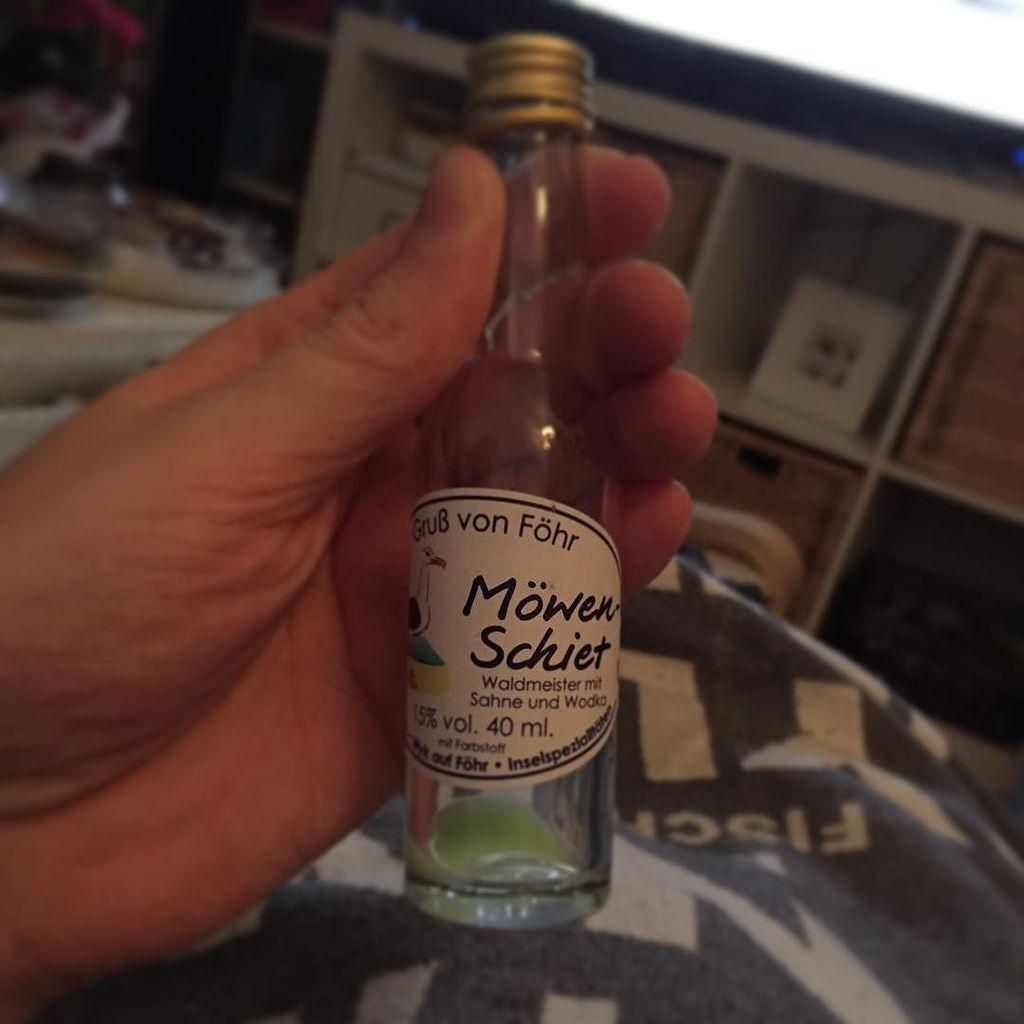<image>
Summarize the visual content of the image. A hand holding an empty 40 ml. bottle. 